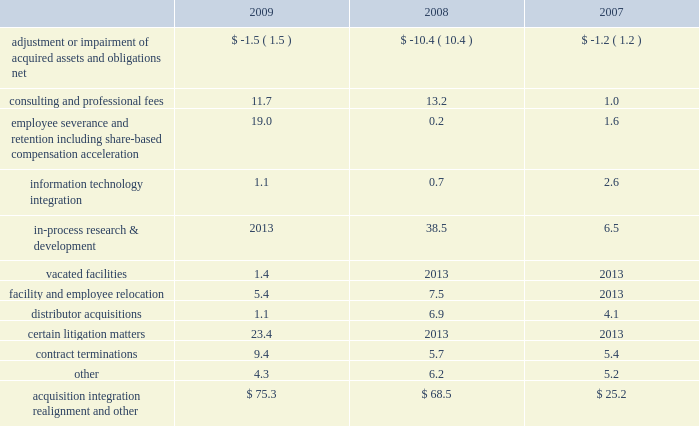Realignment and other 201d expenses .
Acquisition , integration , realignment and other expenses for the years ended december 31 , 2009 , 2008 and 2007 , included ( in millions ) : .
Adjustment or impairment of acquired assets and obligations relates to impairment on assets that were acquired in business combinations or adjustments to certain liabilities of acquired companies due to changes in circumstances surrounding those liabilities subsequent to the related measurement period .
Consulting and professional fees relate to third-party integration consulting performed in a variety of areas such as tax , compliance , logistics and human resources and include third-party fees related to severance and termination benefits matters .
These fees also include legal fees related to litigation matters involving acquired businesses that existed prior to our acquisition or resulted from our acquisition .
During 2009 , we commenced a global realignment initiative to focus on business opportunities that best support our strategic priorities .
As part of this realignment , we initiated changes in our work force , eliminating positions in some areas and increasing others .
Approximately 300 employees from across the globe were affected by these actions .
As a result of these changes in our work force and headcount reductions from acquisitions , we recorded expense of $ 19.0 million related to severance and other employee termination-related costs .
These termination benefits were provided in accordance with our existing or local government policies and are considered ongoing benefits .
These costs were accrued when they became probable and estimable and were recorded as part of other current liabilities .
The majority of these costs were paid during 2009 .
Information technology integration relates to the non- capitalizable costs associated with integrating the information systems of acquired businesses .
In-process research and development charges for 2008 relate to the acquisition of abbott spine .
In-process research and development charges for 2007 relate to the acquisitions of endius and orthosoft .
In 2009 , we ceased using certain leased facilities and , accordingly , recorded expense for the remaining lease payments , less estimated sublease recoveries , and wrote-off any assets being used in those facilities .
Facility and employee relocation relates to costs associated with relocating certain facilities .
Most notably , we consolidated our legacy european distribution centers into a new distribution center in eschbach , germany .
Over the past three years we have acquired a number of u.s .
And foreign-based distributors .
We have incurred various costs related to the acquisition and integration of those businesses .
Certain litigation matters relate to costs recognized during the year for the estimated or actual settlement of various legal matters , including patent litigation matters , commercial litigation matters and matters arising from our acquisitions of certain competitive distributorships in prior years .
We recognize expense for the potential settlement of a legal matter when we believe it is probable that a loss has been incurred and we can reasonably estimate the loss .
In 2009 , we made a concerted effort to settle many of these matters to avoid further litigation costs .
Contract termination costs relate to terminated agreements in connection with the integration of acquired companies .
The terminated contracts primarily relate to sales agents and distribution agreements .
Cash and cash equivalents 2013 we consider all highly liquid investments with an original maturity of three months or less to be cash equivalents .
The carrying amounts reported in the balance sheet for cash and cash equivalents are valued at cost , which approximates their fair value .
Certificates of deposit 2013 we invest in cash deposits with original maturities greater than three months and classify these investments as certificates of deposit on our consolidated balance sheet .
The carrying amounts reported in the balance sheet for certificates of deposit are valued at cost , which approximates their fair value .
Inventories 2013 inventories , net of allowances for obsolete and slow-moving goods , are stated at the lower of cost or market , with cost determined on a first-in first-out basis .
Property , plant and equipment 2013 property , plant and equipment is carried at cost less accumulated depreciation .
Depreciation is computed using the straight-line method based on estimated useful lives of ten to forty years for buildings and improvements and three to eight years for machinery and equipment .
Maintenance and repairs are expensed as incurred .
We review property , plant and equipment for impairment whenever events or changes in circumstances indicate that the carrying value of an asset may not be recoverable .
An impairment loss would be recognized when estimated future undiscounted cash flows relating to the asset are less than its carrying amount .
An impairment loss is measured as the amount by which the carrying amount of an asset exceeds its fair value .
Z i m m e r h o l d i n g s , i n c .
2 0 0 9 f o r m 1 0 - k a n n u a l r e p o r t notes to consolidated financial statements ( continued ) %%transmsg*** transmitting job : c55340 pcn : 043000000 ***%%pcmsg|43 |00008|yes|no|02/24/2010 01:32|0|0|page is valid , no graphics -- color : d| .
What is the percent change in consulting and professional fees from 2008 to 2009? 
Computations: ((13.2 - 11.7) / 11.7)
Answer: 0.12821. 